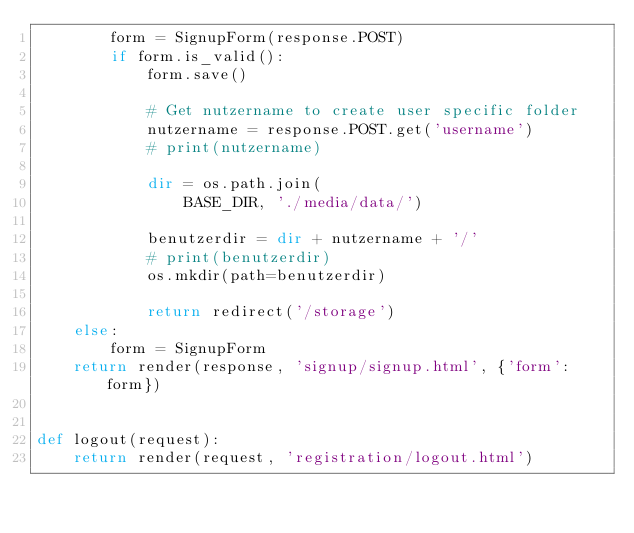Convert code to text. <code><loc_0><loc_0><loc_500><loc_500><_Python_>        form = SignupForm(response.POST)
        if form.is_valid():
            form.save()

            # Get nutzername to create user specific folder
            nutzername = response.POST.get('username')
            # print(nutzername)

            dir = os.path.join(
                BASE_DIR, './media/data/')

            benutzerdir = dir + nutzername + '/'
            # print(benutzerdir)
            os.mkdir(path=benutzerdir)

            return redirect('/storage')
    else:
        form = SignupForm
    return render(response, 'signup/signup.html', {'form': form})


def logout(request):
    return render(request, 'registration/logout.html')
</code> 